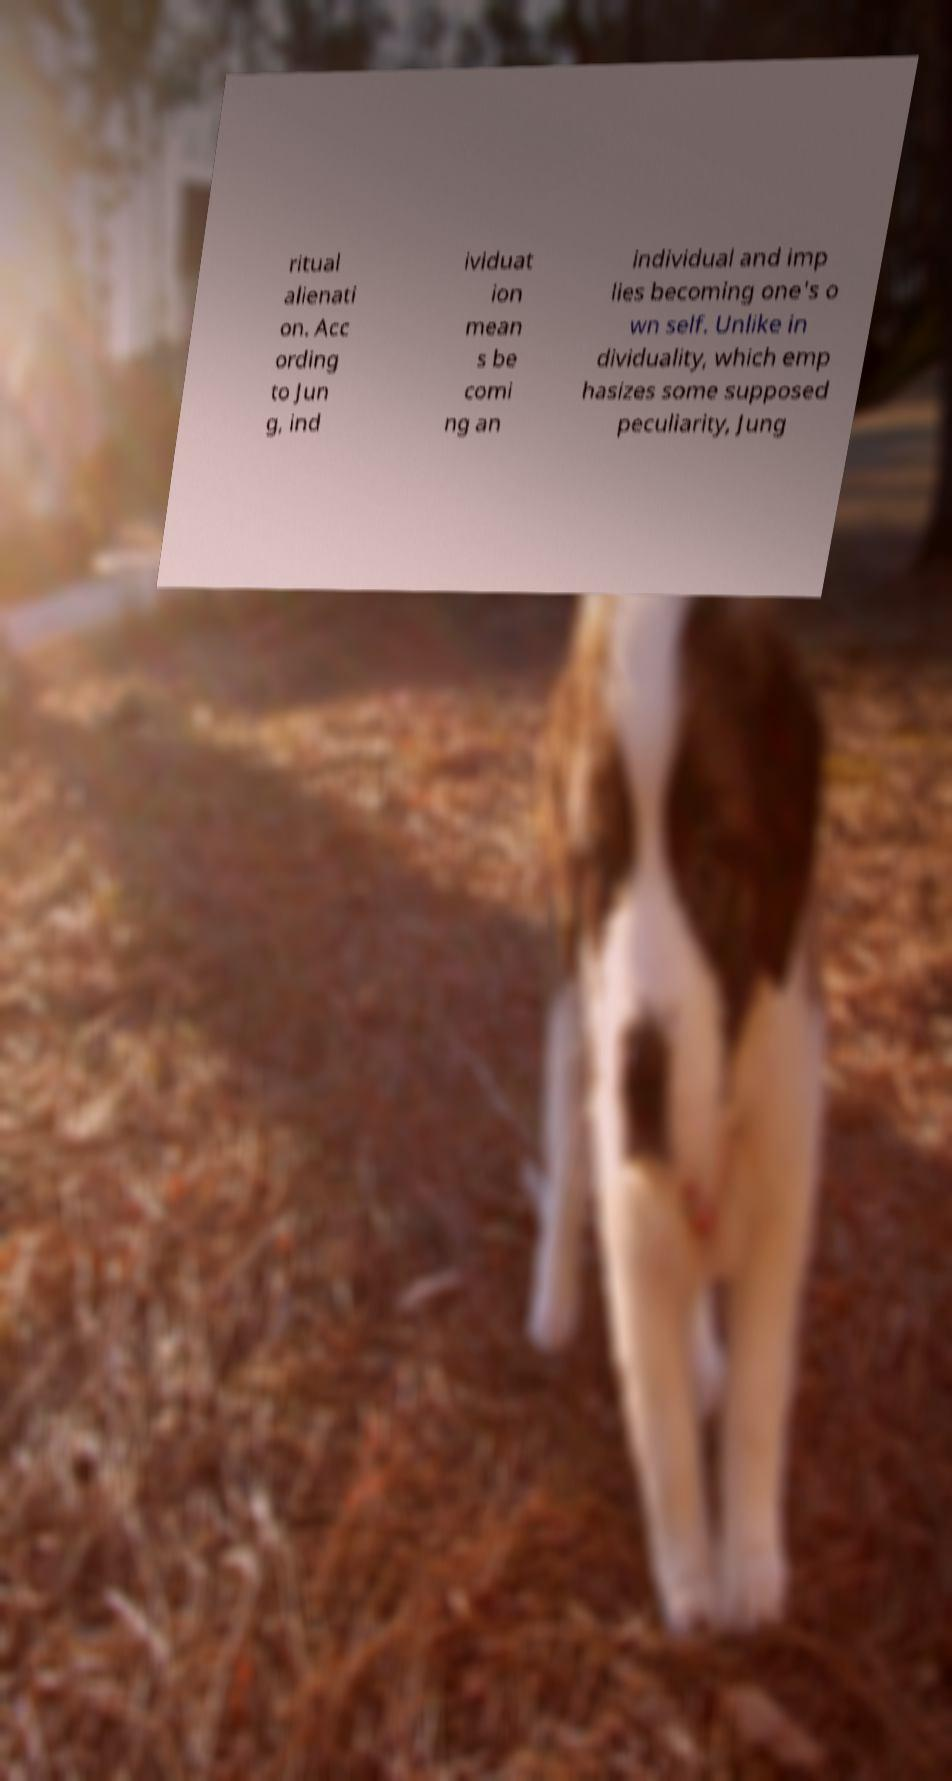I need the written content from this picture converted into text. Can you do that? ritual alienati on. Acc ording to Jun g, ind ividuat ion mean s be comi ng an individual and imp lies becoming one's o wn self. Unlike in dividuality, which emp hasizes some supposed peculiarity, Jung 